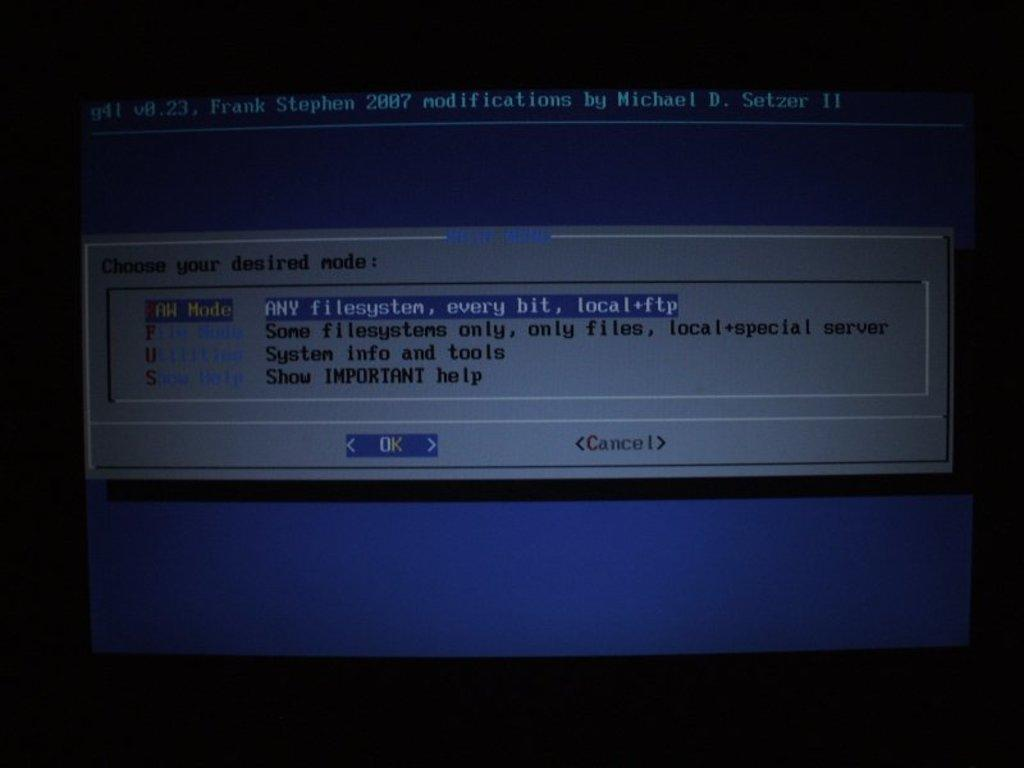<image>
Write a terse but informative summary of the picture. A system file transfer protocol was initiated using the raw mode attributed with g41 v0.23 and year 2007 